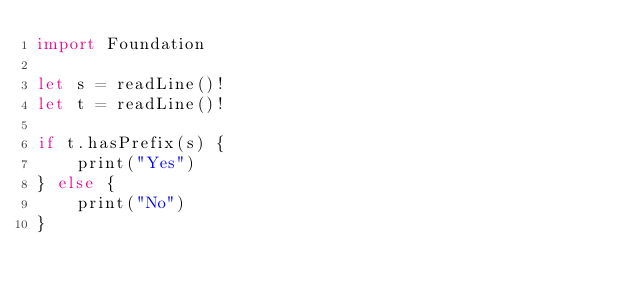<code> <loc_0><loc_0><loc_500><loc_500><_Swift_>import Foundation

let s = readLine()!
let t = readLine()!

if t.hasPrefix(s) {
    print("Yes")
} else {
    print("No")
}

</code> 